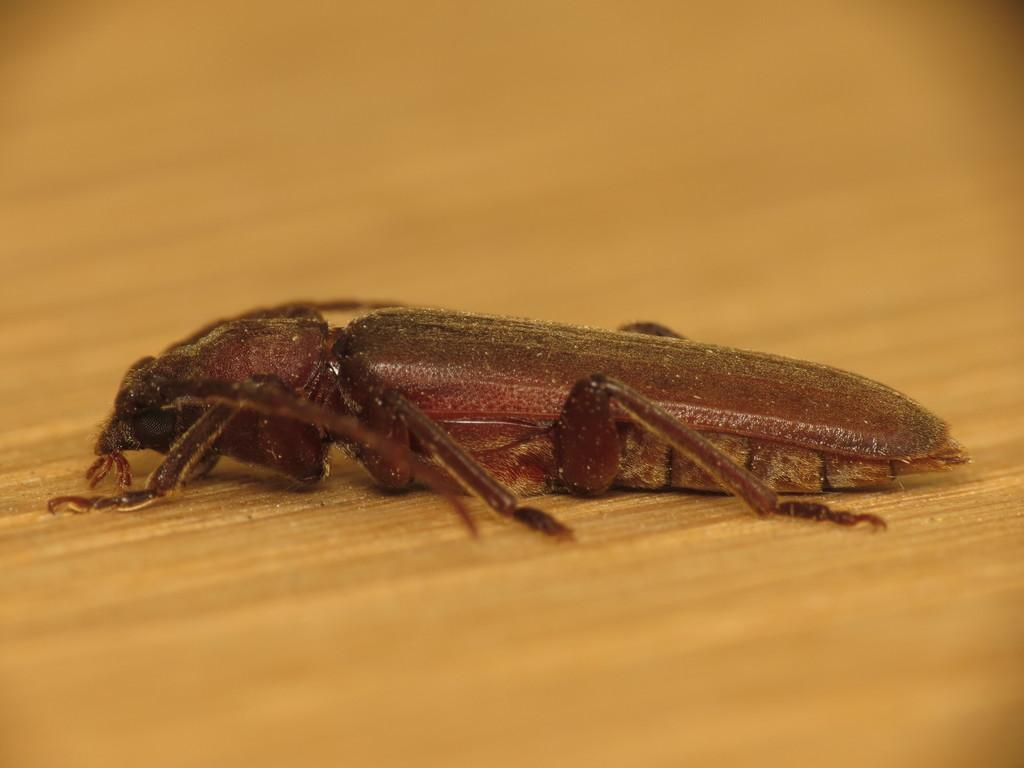What type of creature is present in the image? There is an insect in the image. What surface is the insect situated on? The insect is on a wooden surface. How can you describe the edges of the image? The top and bottom of the image are blurred. How many feet does the insect have in the image? The number of feet the insect has cannot be determined from the image alone. What time of day is it in the image? The time of day cannot be determined from the image alone. Can you see the insect's tongue in the image? There is no indication of the insect's tongue in the image. 